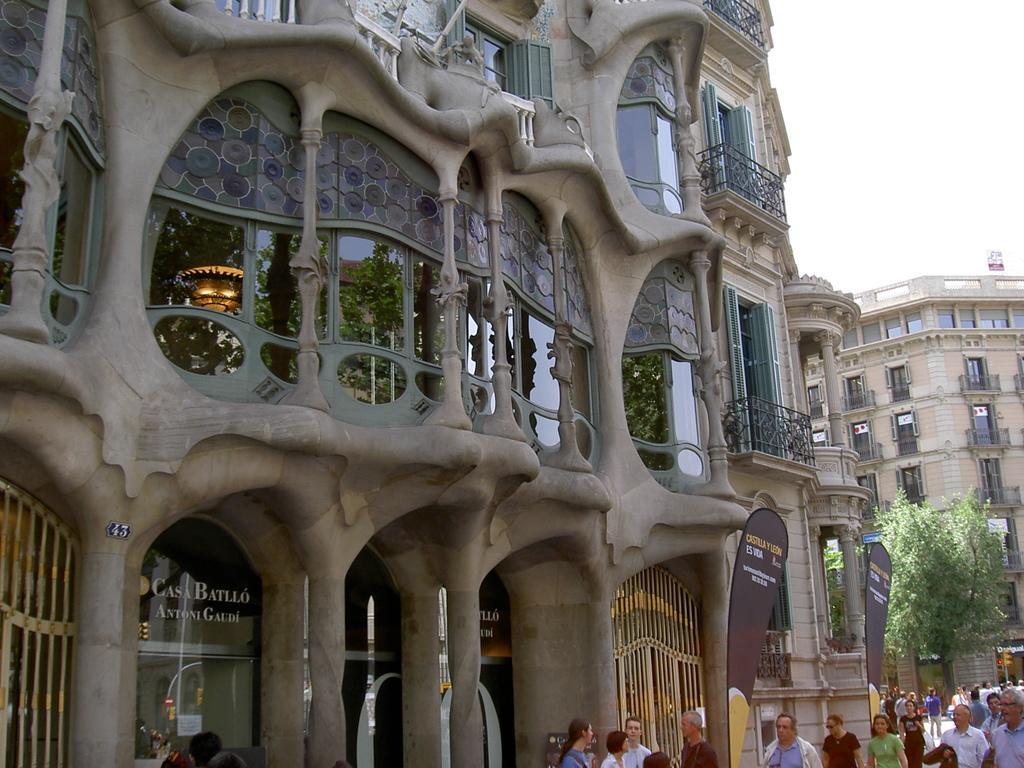In one or two sentences, can you explain what this image depicts? At the bottom we can see few persons. In the background there are buildings, windows, glass doors, hoardings, trees, fences and sky. 